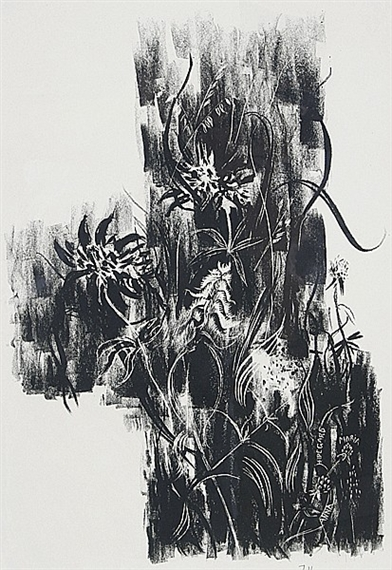Can you tell me more about the techniques used in this artwork? This artwork employs printmaking techniques, which involve transferring ink from a matrix to a substrate, typically paper. The intricate lines and patterns you see are likely the result of processes such as etching or lithography, where the artist uses tools to carve or draw on a surface that then prints onto paper. These techniques allow for high levels of detail, texture, and variation, which are evident in the fluid, organic shapes in this piece. What emotions or feelings does this artwork evoke for you? The artwork evokes a sense of dynamic movement and energy, almost as if the lines are alive and in constant motion. This sense of fluidity can bring about feelings of excitement and curiosity. The stark contrast between black and white may also evoke feelings of intensity and contemplation, as the mind tries to follow the elaborate paths of the lines. Overall, it inspires a sense of wonder at the complexity and beauty of abstract forms. Imagine if this artwork were part of a living ecosystem, what kind of life forms would inhabit it? In a world where this artwork represents a living ecosystem, one might imagine ethereal, bioluminescent creatures gracefully navigating through the swirling lines and shapes. These life forms could be akin to jellyfish or plankton, with delicate tendrils and glowing bodies that pulse and change color as they move. The ecosystem would be a mesmerizing dance of light and shadow, with organisms that thrive in the deep contrasts and fluid spaces of the artwork, creating a surreal, almost otherworldly environment. 